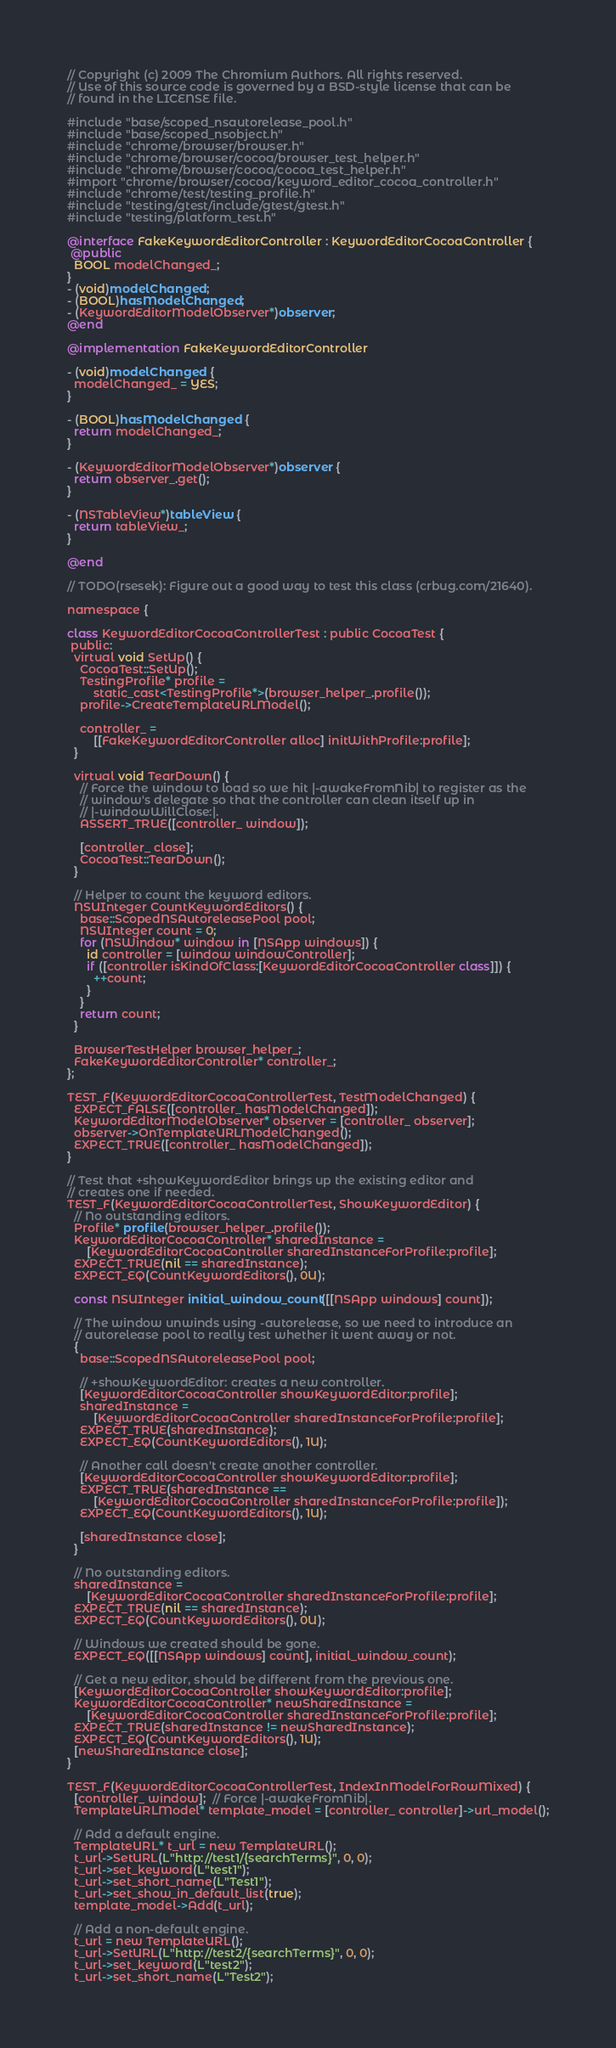<code> <loc_0><loc_0><loc_500><loc_500><_ObjectiveC_>// Copyright (c) 2009 The Chromium Authors. All rights reserved.
// Use of this source code is governed by a BSD-style license that can be
// found in the LICENSE file.

#include "base/scoped_nsautorelease_pool.h"
#include "base/scoped_nsobject.h"
#include "chrome/browser/browser.h"
#include "chrome/browser/cocoa/browser_test_helper.h"
#include "chrome/browser/cocoa/cocoa_test_helper.h"
#import "chrome/browser/cocoa/keyword_editor_cocoa_controller.h"
#include "chrome/test/testing_profile.h"
#include "testing/gtest/include/gtest/gtest.h"
#include "testing/platform_test.h"

@interface FakeKeywordEditorController : KeywordEditorCocoaController {
 @public
  BOOL modelChanged_;
}
- (void)modelChanged;
- (BOOL)hasModelChanged;
- (KeywordEditorModelObserver*)observer;
@end

@implementation FakeKeywordEditorController

- (void)modelChanged {
  modelChanged_ = YES;
}

- (BOOL)hasModelChanged {
  return modelChanged_;
}

- (KeywordEditorModelObserver*)observer {
  return observer_.get();
}

- (NSTableView*)tableView {
  return tableView_;
}

@end

// TODO(rsesek): Figure out a good way to test this class (crbug.com/21640).

namespace {

class KeywordEditorCocoaControllerTest : public CocoaTest {
 public:
  virtual void SetUp() {
    CocoaTest::SetUp();
    TestingProfile* profile =
        static_cast<TestingProfile*>(browser_helper_.profile());
    profile->CreateTemplateURLModel();

    controller_ =
        [[FakeKeywordEditorController alloc] initWithProfile:profile];
  }

  virtual void TearDown() {
    // Force the window to load so we hit |-awakeFromNib| to register as the
    // window's delegate so that the controller can clean itself up in
    // |-windowWillClose:|.
    ASSERT_TRUE([controller_ window]);

    [controller_ close];
    CocoaTest::TearDown();
  }

  // Helper to count the keyword editors.
  NSUInteger CountKeywordEditors() {
    base::ScopedNSAutoreleasePool pool;
    NSUInteger count = 0;
    for (NSWindow* window in [NSApp windows]) {
      id controller = [window windowController];
      if ([controller isKindOfClass:[KeywordEditorCocoaController class]]) {
        ++count;
      }
    }
    return count;
  }

  BrowserTestHelper browser_helper_;
  FakeKeywordEditorController* controller_;
};

TEST_F(KeywordEditorCocoaControllerTest, TestModelChanged) {
  EXPECT_FALSE([controller_ hasModelChanged]);
  KeywordEditorModelObserver* observer = [controller_ observer];
  observer->OnTemplateURLModelChanged();
  EXPECT_TRUE([controller_ hasModelChanged]);
}

// Test that +showKeywordEditor brings up the existing editor and
// creates one if needed.
TEST_F(KeywordEditorCocoaControllerTest, ShowKeywordEditor) {
  // No outstanding editors.
  Profile* profile(browser_helper_.profile());
  KeywordEditorCocoaController* sharedInstance =
      [KeywordEditorCocoaController sharedInstanceForProfile:profile];
  EXPECT_TRUE(nil == sharedInstance);
  EXPECT_EQ(CountKeywordEditors(), 0U);

  const NSUInteger initial_window_count([[NSApp windows] count]);

  // The window unwinds using -autorelease, so we need to introduce an
  // autorelease pool to really test whether it went away or not.
  {
    base::ScopedNSAutoreleasePool pool;

    // +showKeywordEditor: creates a new controller.
    [KeywordEditorCocoaController showKeywordEditor:profile];
    sharedInstance =
        [KeywordEditorCocoaController sharedInstanceForProfile:profile];
    EXPECT_TRUE(sharedInstance);
    EXPECT_EQ(CountKeywordEditors(), 1U);

    // Another call doesn't create another controller.
    [KeywordEditorCocoaController showKeywordEditor:profile];
    EXPECT_TRUE(sharedInstance ==
        [KeywordEditorCocoaController sharedInstanceForProfile:profile]);
    EXPECT_EQ(CountKeywordEditors(), 1U);

    [sharedInstance close];
  }

  // No outstanding editors.
  sharedInstance =
      [KeywordEditorCocoaController sharedInstanceForProfile:profile];
  EXPECT_TRUE(nil == sharedInstance);
  EXPECT_EQ(CountKeywordEditors(), 0U);

  // Windows we created should be gone.
  EXPECT_EQ([[NSApp windows] count], initial_window_count);

  // Get a new editor, should be different from the previous one.
  [KeywordEditorCocoaController showKeywordEditor:profile];
  KeywordEditorCocoaController* newSharedInstance =
      [KeywordEditorCocoaController sharedInstanceForProfile:profile];
  EXPECT_TRUE(sharedInstance != newSharedInstance);
  EXPECT_EQ(CountKeywordEditors(), 1U);
  [newSharedInstance close];
}

TEST_F(KeywordEditorCocoaControllerTest, IndexInModelForRowMixed) {
  [controller_ window];  // Force |-awakeFromNib|.
  TemplateURLModel* template_model = [controller_ controller]->url_model();

  // Add a default engine.
  TemplateURL* t_url = new TemplateURL();
  t_url->SetURL(L"http://test1/{searchTerms}", 0, 0);
  t_url->set_keyword(L"test1");
  t_url->set_short_name(L"Test1");
  t_url->set_show_in_default_list(true);
  template_model->Add(t_url);

  // Add a non-default engine.
  t_url = new TemplateURL();
  t_url->SetURL(L"http://test2/{searchTerms}", 0, 0);
  t_url->set_keyword(L"test2");
  t_url->set_short_name(L"Test2");</code> 